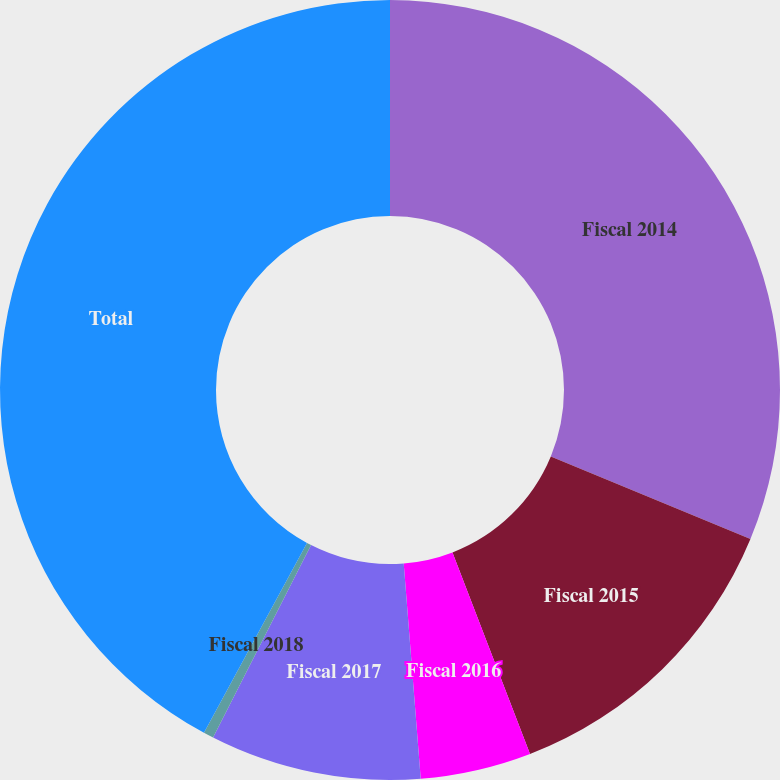<chart> <loc_0><loc_0><loc_500><loc_500><pie_chart><fcel>Fiscal 2014<fcel>Fiscal 2015<fcel>Fiscal 2016<fcel>Fiscal 2017<fcel>Fiscal 2018<fcel>Total<nl><fcel>31.24%<fcel>12.92%<fcel>4.59%<fcel>8.75%<fcel>0.42%<fcel>42.09%<nl></chart> 